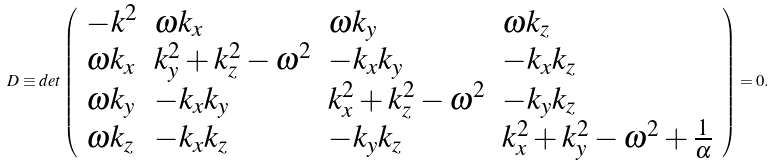<formula> <loc_0><loc_0><loc_500><loc_500>D \equiv d e t \left ( \begin{array} { l l l l } { { - k ^ { 2 } } } & { { \omega k _ { x } } } & { { \omega k _ { y } } } & { { \omega k _ { z } } } \\ { { \omega k _ { x } } } & { { k _ { y } ^ { 2 } + k _ { z } ^ { 2 } - \omega ^ { 2 } } } & { { - k _ { x } k _ { y } } } & { { - k _ { x } k _ { z } } } \\ { { \omega k _ { y } } } & { { - k _ { x } k _ { y } } } & { { k _ { x } ^ { 2 } + k _ { z } ^ { 2 } - \omega ^ { 2 } } } & { { - k _ { y } k _ { z } } } \\ { { \omega k _ { z } } } & { { - k _ { x } k _ { z } } } & { { - k _ { y } k _ { z } } } & { { k _ { x } ^ { 2 } + k _ { y } ^ { 2 } - \omega ^ { 2 } + { \frac { 1 } { \alpha } } } } \end{array} \right ) = 0 .</formula> 